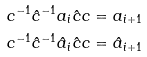Convert formula to latex. <formula><loc_0><loc_0><loc_500><loc_500>c ^ { - 1 } \hat { c } ^ { - 1 } a _ { i } \hat { c } c & = a _ { i + 1 } \\ c ^ { - 1 } \hat { c } ^ { - 1 } \hat { a } _ { i } \hat { c } c & = \hat { a } _ { i + 1 }</formula> 